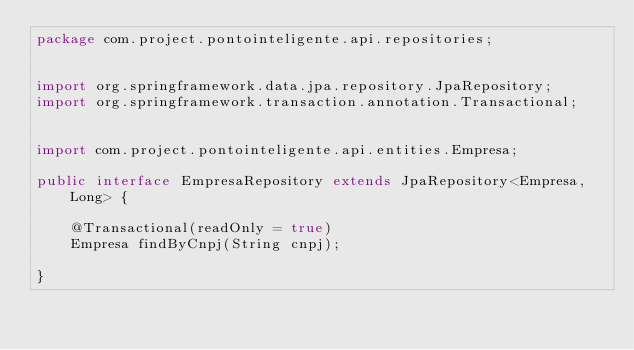Convert code to text. <code><loc_0><loc_0><loc_500><loc_500><_Java_>package com.project.pontointeligente.api.repositories;


import org.springframework.data.jpa.repository.JpaRepository;
import org.springframework.transaction.annotation.Transactional;


import com.project.pontointeligente.api.entities.Empresa;

public interface EmpresaRepository extends JpaRepository<Empresa, Long> {
	
	@Transactional(readOnly = true)
	Empresa findByCnpj(String cnpj);

}
</code> 